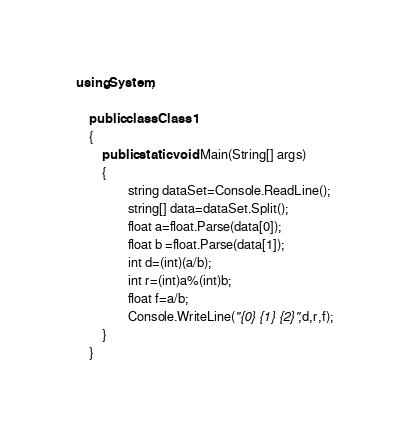Convert code to text. <code><loc_0><loc_0><loc_500><loc_500><_C#_>using System;

	public class Class1
	{
		public static void Main(String[] args)
		{
				string dataSet=Console.ReadLine();
				string[] data=dataSet.Split();
				float a=float.Parse(data[0]);
				float b =float.Parse(data[1]);
				int d=(int)(a/b);
				int r=(int)a%(int)b;
				float f=a/b;
				Console.WriteLine("{0} {1} {2}",d,r,f);
		}
	}</code> 